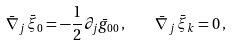Convert formula to latex. <formula><loc_0><loc_0><loc_500><loc_500>\bar { \nabla } _ { j } \, \bar { \xi } _ { 0 } = - \frac { 1 } { 2 } \partial _ { j } \bar { g } _ { 0 0 } \, , \quad \bar { \nabla } _ { j } \, \bar { \xi } _ { k } = 0 \, ,</formula> 